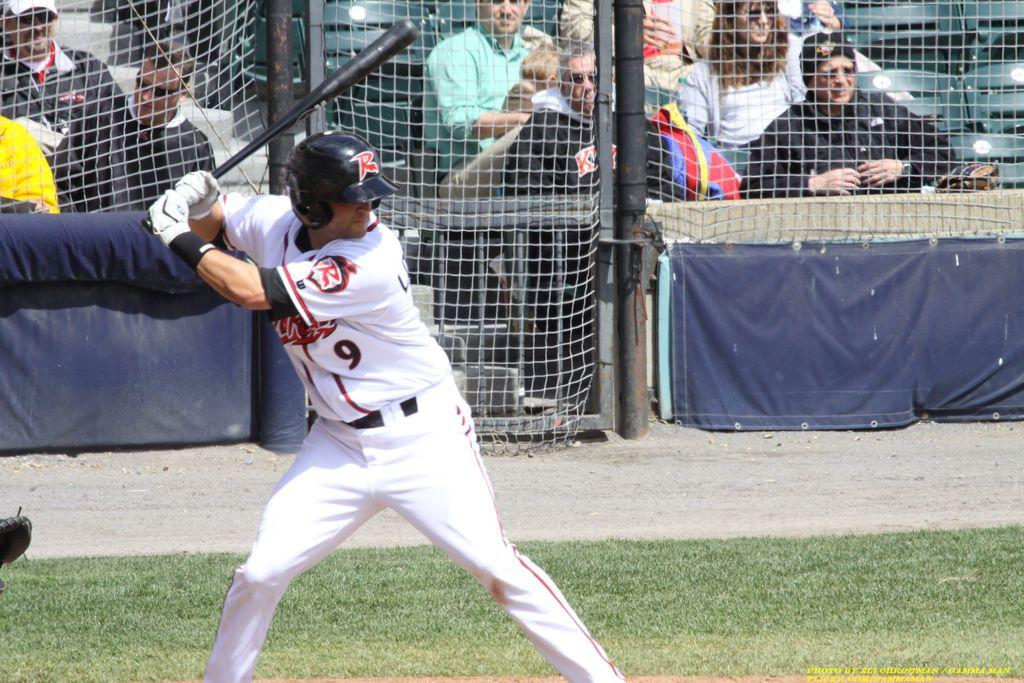<image>
Create a compact narrative representing the image presented. a jersey that has the number 9 on it as people play baseball 